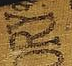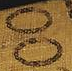What text is displayed in these images sequentially, separated by a semicolon? ORY; OO 